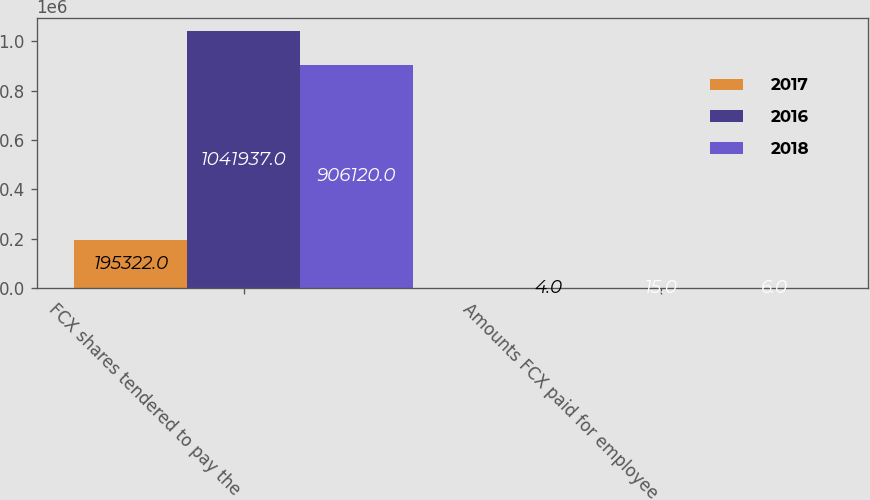<chart> <loc_0><loc_0><loc_500><loc_500><stacked_bar_chart><ecel><fcel>FCX shares tendered to pay the<fcel>Amounts FCX paid for employee<nl><fcel>2017<fcel>195322<fcel>4<nl><fcel>2016<fcel>1.04194e+06<fcel>15<nl><fcel>2018<fcel>906120<fcel>6<nl></chart> 